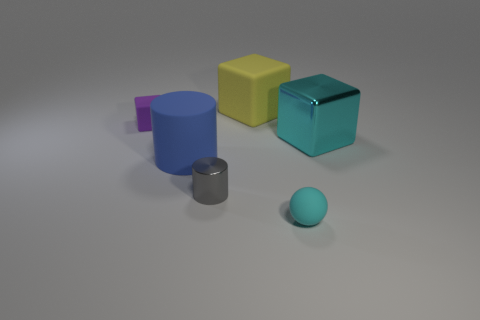Imagine this image is for an educational toy catalog. What might be the educational purpose of these objects? These objects could serve multiple educational purposes in an educational toy catalog. For instance, they could be used to teach basic geometric shapes and colors. Children could learn about the properties of different materials, as some objects are made of rubber and others look metallic. Additionally, the varying sizes and the interaction between light and shadows on these objects could introduce concepts of spatial awareness, perspective, and physics, such as how light interacts with surfaces to create shadows. 